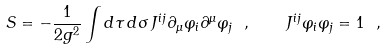<formula> <loc_0><loc_0><loc_500><loc_500>S = - \frac { 1 } { 2 g ^ { 2 } } \int d \tau \, d \sigma \, J ^ { i j } \partial _ { \mu } \varphi _ { i } \partial ^ { \mu } \varphi _ { j } \ , \quad J ^ { i j } \varphi _ { i } \varphi _ { j } = 1 \ ,</formula> 